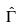Convert formula to latex. <formula><loc_0><loc_0><loc_500><loc_500>\hat { \Gamma }</formula> 